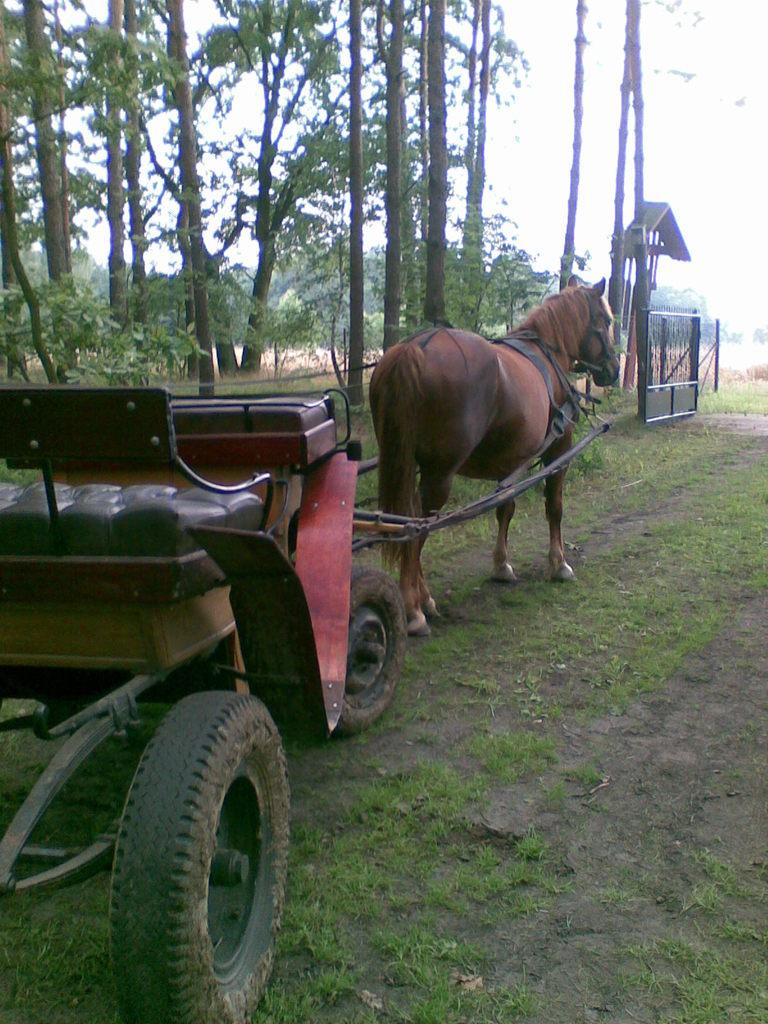What type of vehicle is being pulled in the image? There is a horse drawn cart in the image. What is the cart moving on? The cart is moving on the grass. What structure can be seen in the image? There is a gate visible in the image. What type of vegetation is present in the image? There are trees in the image. What type of silk is being used to create the station in the image? There is no silk or station present in the image; it features a horse drawn cart moving on the grass with a gate and trees in the background. 